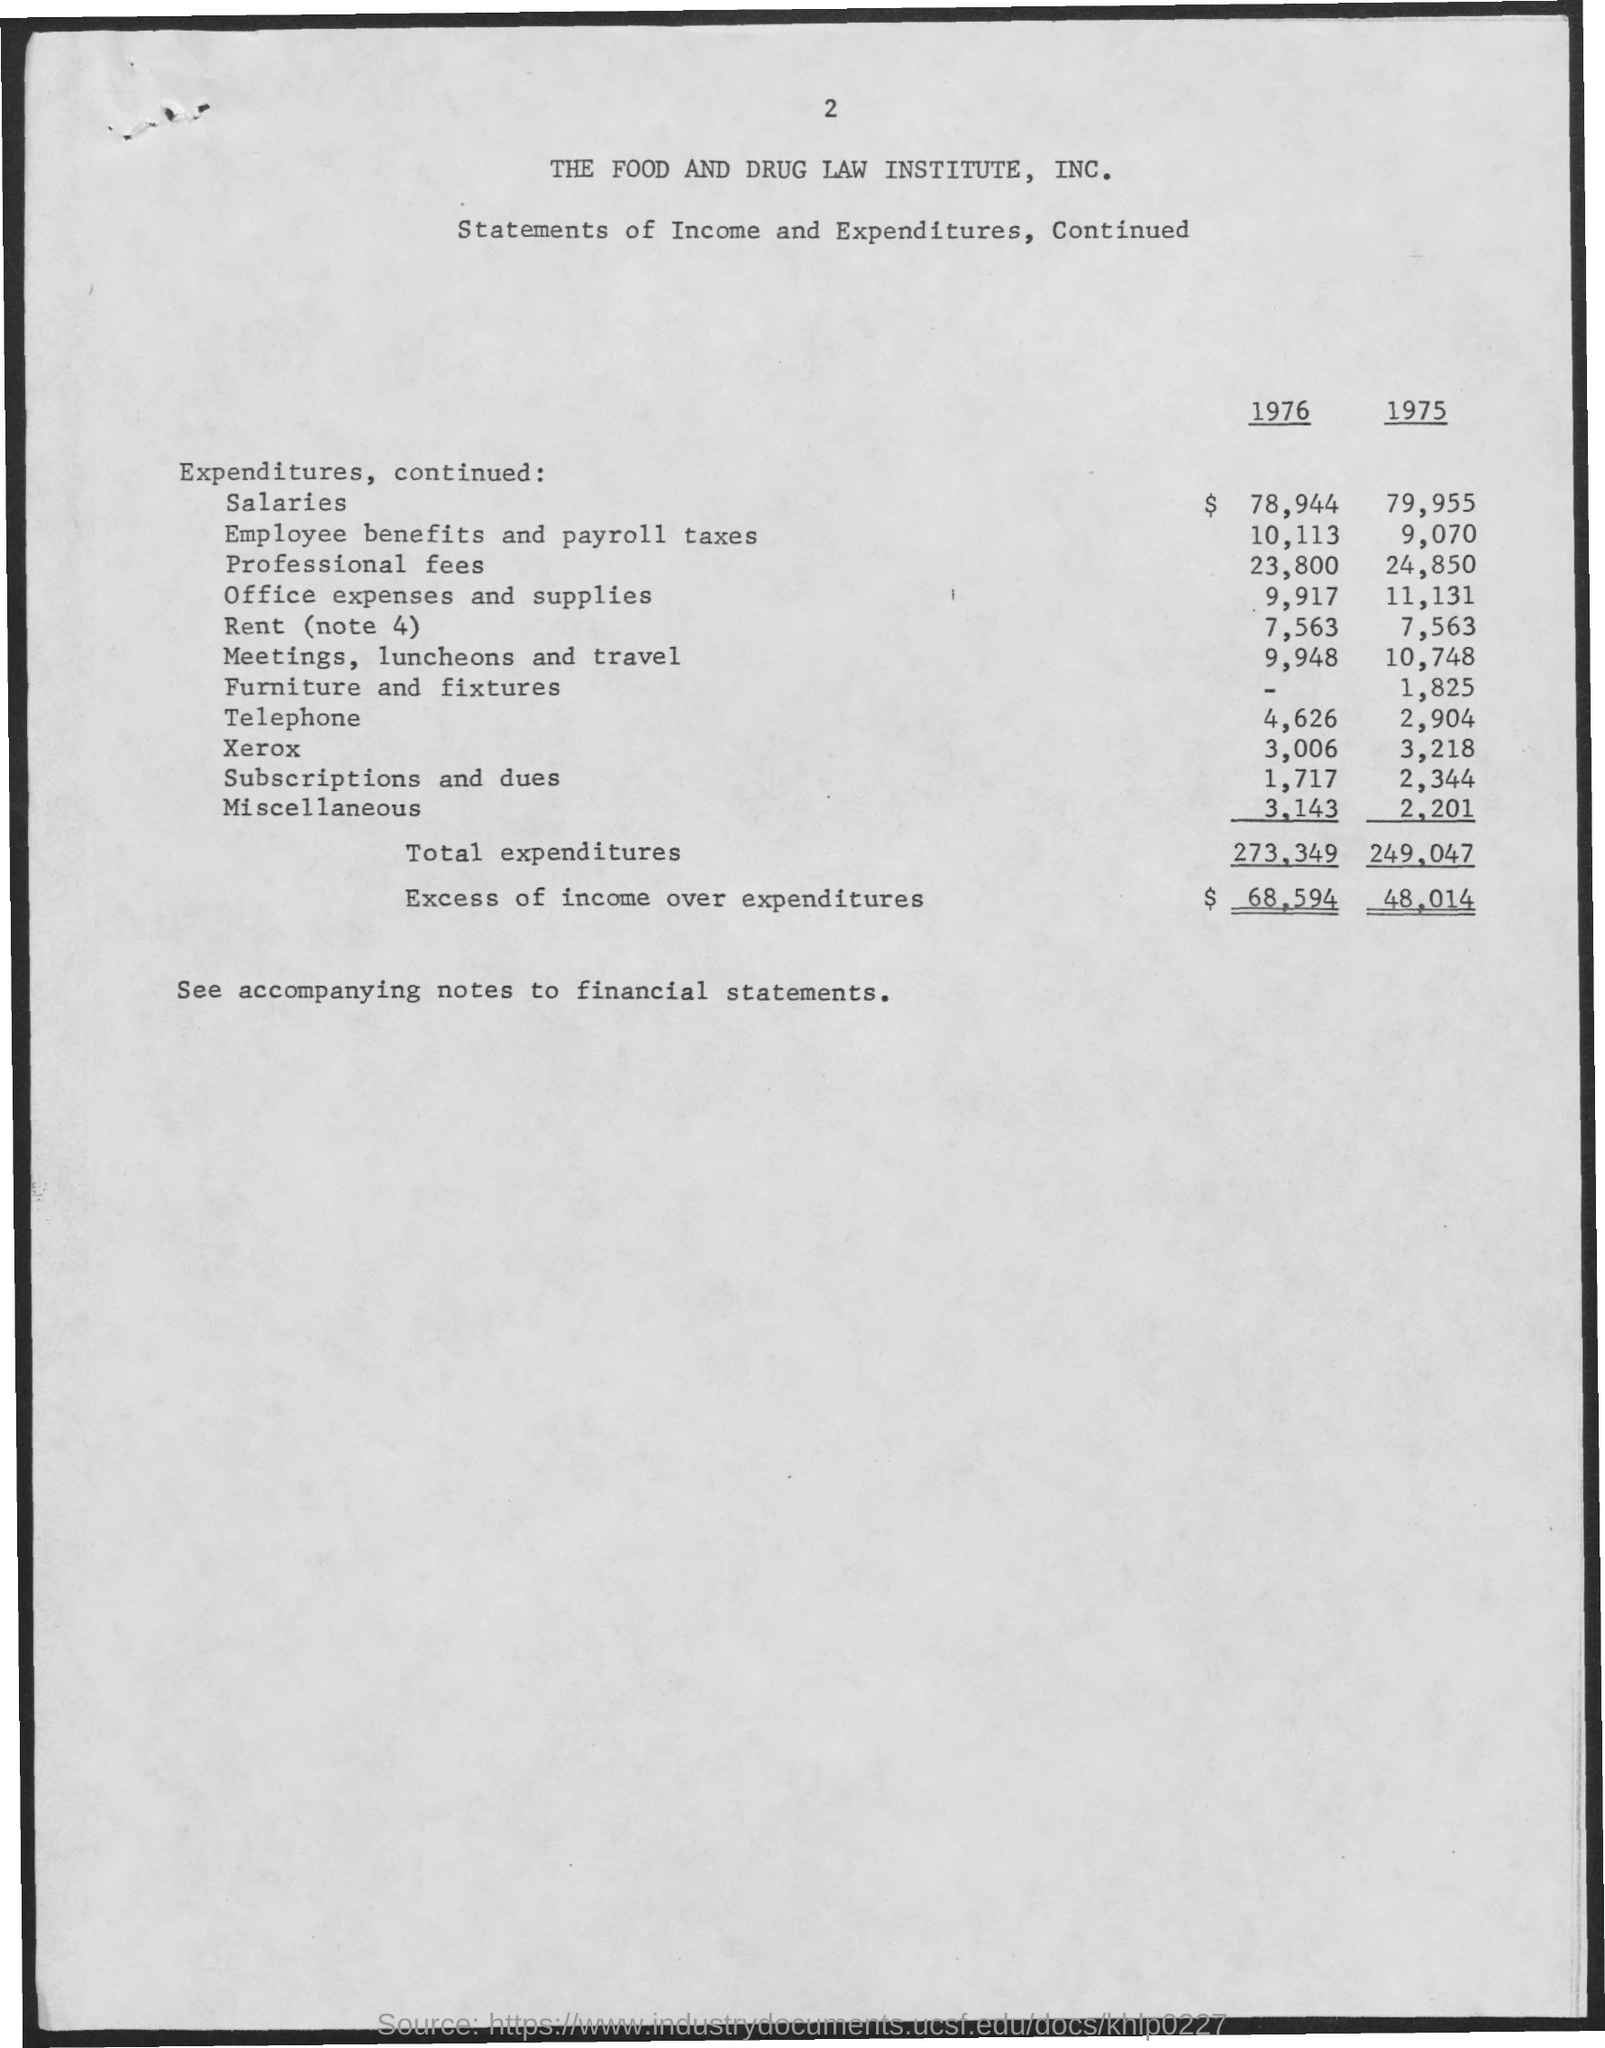Indicate a few pertinent items in this graphic. The Food and Drug Law Institute is the name of the institute mentioned in the given page. The amount of excess of income over expenditures in the year 1976 was $68,594. The amount for professional fees in the year 1976 was $23,800. In the year 1976, a total of $273,349 was expended. The amount for furniture and fixtures in the year 1975 was $1,825. 